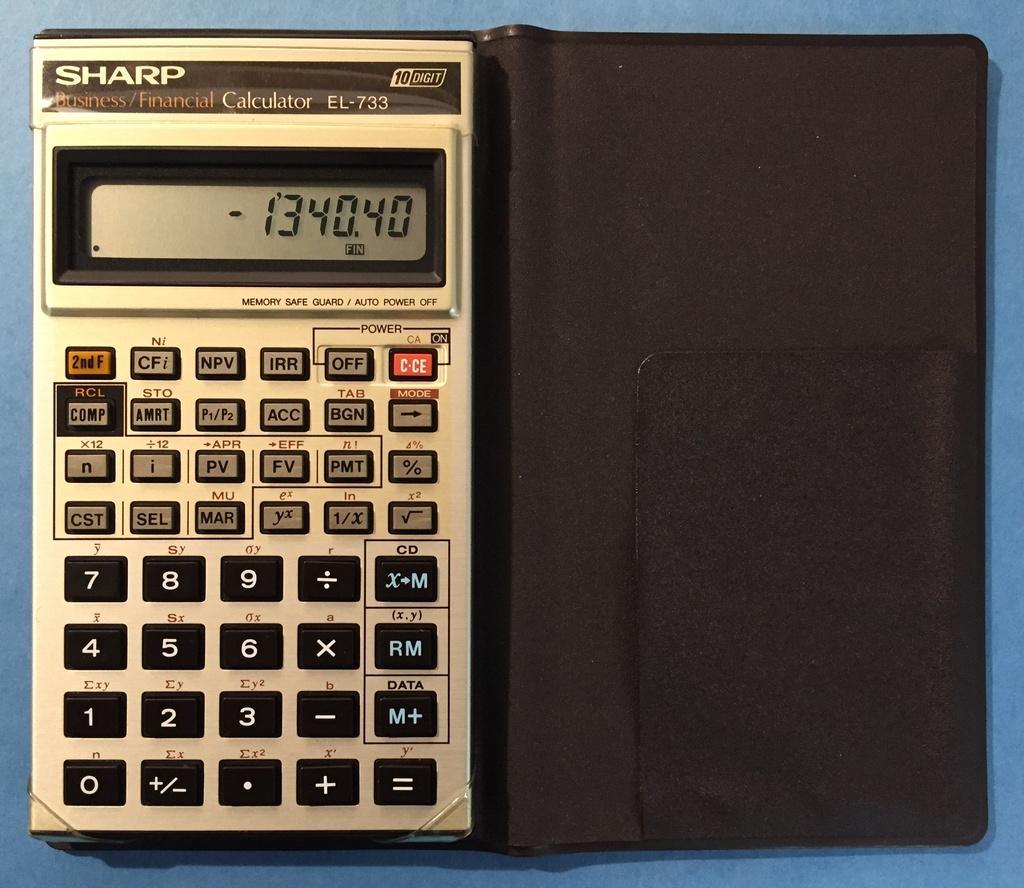Could you give a brief overview of what you see in this image? In this image in the center there is one calculator, and in the background there is a table. 